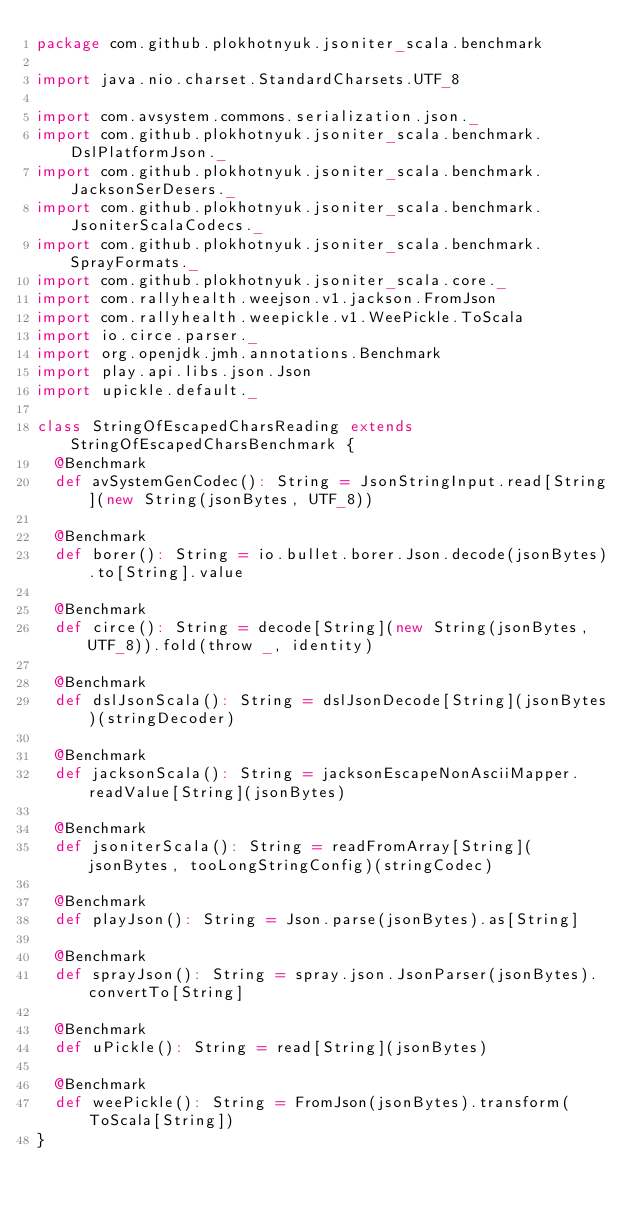Convert code to text. <code><loc_0><loc_0><loc_500><loc_500><_Scala_>package com.github.plokhotnyuk.jsoniter_scala.benchmark

import java.nio.charset.StandardCharsets.UTF_8

import com.avsystem.commons.serialization.json._
import com.github.plokhotnyuk.jsoniter_scala.benchmark.DslPlatformJson._
import com.github.plokhotnyuk.jsoniter_scala.benchmark.JacksonSerDesers._
import com.github.plokhotnyuk.jsoniter_scala.benchmark.JsoniterScalaCodecs._
import com.github.plokhotnyuk.jsoniter_scala.benchmark.SprayFormats._
import com.github.plokhotnyuk.jsoniter_scala.core._
import com.rallyhealth.weejson.v1.jackson.FromJson
import com.rallyhealth.weepickle.v1.WeePickle.ToScala
import io.circe.parser._
import org.openjdk.jmh.annotations.Benchmark
import play.api.libs.json.Json
import upickle.default._

class StringOfEscapedCharsReading extends StringOfEscapedCharsBenchmark {
  @Benchmark
  def avSystemGenCodec(): String = JsonStringInput.read[String](new String(jsonBytes, UTF_8))

  @Benchmark
  def borer(): String = io.bullet.borer.Json.decode(jsonBytes).to[String].value

  @Benchmark
  def circe(): String = decode[String](new String(jsonBytes, UTF_8)).fold(throw _, identity)

  @Benchmark
  def dslJsonScala(): String = dslJsonDecode[String](jsonBytes)(stringDecoder)

  @Benchmark
  def jacksonScala(): String = jacksonEscapeNonAsciiMapper.readValue[String](jsonBytes)

  @Benchmark
  def jsoniterScala(): String = readFromArray[String](jsonBytes, tooLongStringConfig)(stringCodec)

  @Benchmark
  def playJson(): String = Json.parse(jsonBytes).as[String]

  @Benchmark
  def sprayJson(): String = spray.json.JsonParser(jsonBytes).convertTo[String]

  @Benchmark
  def uPickle(): String = read[String](jsonBytes)

  @Benchmark
  def weePickle(): String = FromJson(jsonBytes).transform(ToScala[String])
}</code> 